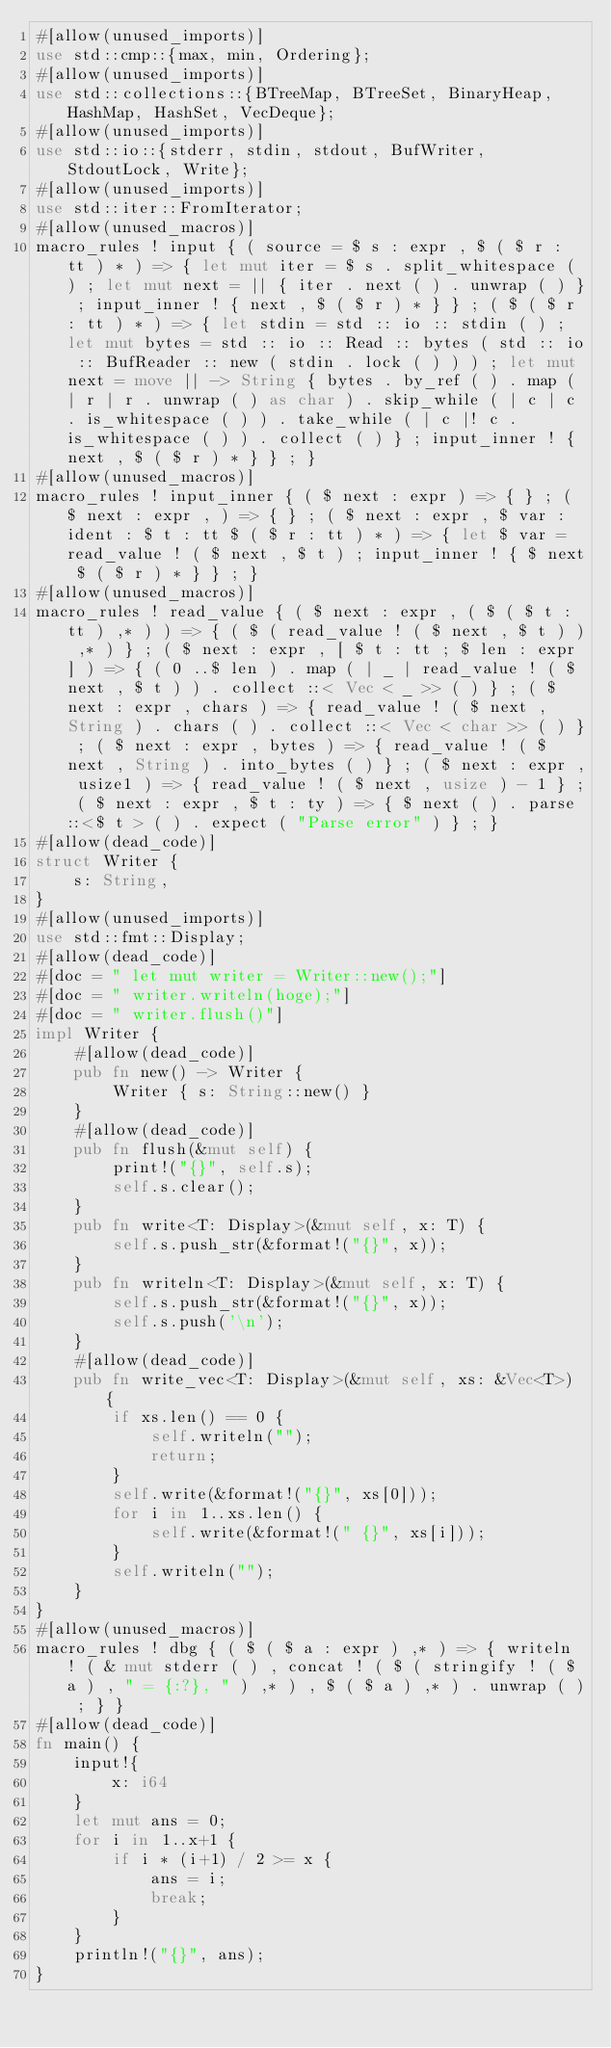<code> <loc_0><loc_0><loc_500><loc_500><_Rust_>#[allow(unused_imports)]
use std::cmp::{max, min, Ordering};
#[allow(unused_imports)]
use std::collections::{BTreeMap, BTreeSet, BinaryHeap, HashMap, HashSet, VecDeque};
#[allow(unused_imports)]
use std::io::{stderr, stdin, stdout, BufWriter, StdoutLock, Write};
#[allow(unused_imports)]
use std::iter::FromIterator;
#[allow(unused_macros)]
macro_rules ! input { ( source = $ s : expr , $ ( $ r : tt ) * ) => { let mut iter = $ s . split_whitespace ( ) ; let mut next = || { iter . next ( ) . unwrap ( ) } ; input_inner ! { next , $ ( $ r ) * } } ; ( $ ( $ r : tt ) * ) => { let stdin = std :: io :: stdin ( ) ; let mut bytes = std :: io :: Read :: bytes ( std :: io :: BufReader :: new ( stdin . lock ( ) ) ) ; let mut next = move || -> String { bytes . by_ref ( ) . map ( | r | r . unwrap ( ) as char ) . skip_while ( | c | c . is_whitespace ( ) ) . take_while ( | c |! c . is_whitespace ( ) ) . collect ( ) } ; input_inner ! { next , $ ( $ r ) * } } ; }
#[allow(unused_macros)]
macro_rules ! input_inner { ( $ next : expr ) => { } ; ( $ next : expr , ) => { } ; ( $ next : expr , $ var : ident : $ t : tt $ ( $ r : tt ) * ) => { let $ var = read_value ! ( $ next , $ t ) ; input_inner ! { $ next $ ( $ r ) * } } ; }
#[allow(unused_macros)]
macro_rules ! read_value { ( $ next : expr , ( $ ( $ t : tt ) ,* ) ) => { ( $ ( read_value ! ( $ next , $ t ) ) ,* ) } ; ( $ next : expr , [ $ t : tt ; $ len : expr ] ) => { ( 0 ..$ len ) . map ( | _ | read_value ! ( $ next , $ t ) ) . collect ::< Vec < _ >> ( ) } ; ( $ next : expr , chars ) => { read_value ! ( $ next , String ) . chars ( ) . collect ::< Vec < char >> ( ) } ; ( $ next : expr , bytes ) => { read_value ! ( $ next , String ) . into_bytes ( ) } ; ( $ next : expr , usize1 ) => { read_value ! ( $ next , usize ) - 1 } ; ( $ next : expr , $ t : ty ) => { $ next ( ) . parse ::<$ t > ( ) . expect ( "Parse error" ) } ; }
#[allow(dead_code)]
struct Writer {
    s: String,
}
#[allow(unused_imports)]
use std::fmt::Display;
#[allow(dead_code)]
#[doc = " let mut writer = Writer::new();"]
#[doc = " writer.writeln(hoge);"]
#[doc = " writer.flush()"]
impl Writer {
    #[allow(dead_code)]
    pub fn new() -> Writer {
        Writer { s: String::new() }
    }
    #[allow(dead_code)]
    pub fn flush(&mut self) {
        print!("{}", self.s);
        self.s.clear();
    }
    pub fn write<T: Display>(&mut self, x: T) {
        self.s.push_str(&format!("{}", x));
    }
    pub fn writeln<T: Display>(&mut self, x: T) {
        self.s.push_str(&format!("{}", x));
        self.s.push('\n');
    }
    #[allow(dead_code)]
    pub fn write_vec<T: Display>(&mut self, xs: &Vec<T>) {
        if xs.len() == 0 {
            self.writeln("");
            return;
        }
        self.write(&format!("{}", xs[0]));
        for i in 1..xs.len() {
            self.write(&format!(" {}", xs[i]));
        }
        self.writeln("");
    }
}
#[allow(unused_macros)]
macro_rules ! dbg { ( $ ( $ a : expr ) ,* ) => { writeln ! ( & mut stderr ( ) , concat ! ( $ ( stringify ! ( $ a ) , " = {:?}, " ) ,* ) , $ ( $ a ) ,* ) . unwrap ( ) ; } }
#[allow(dead_code)]
fn main() {
    input!{
        x: i64
    }
    let mut ans = 0;
    for i in 1..x+1 {
        if i * (i+1) / 2 >= x {
            ans = i;
            break;
        }
    }
    println!("{}", ans);
}</code> 